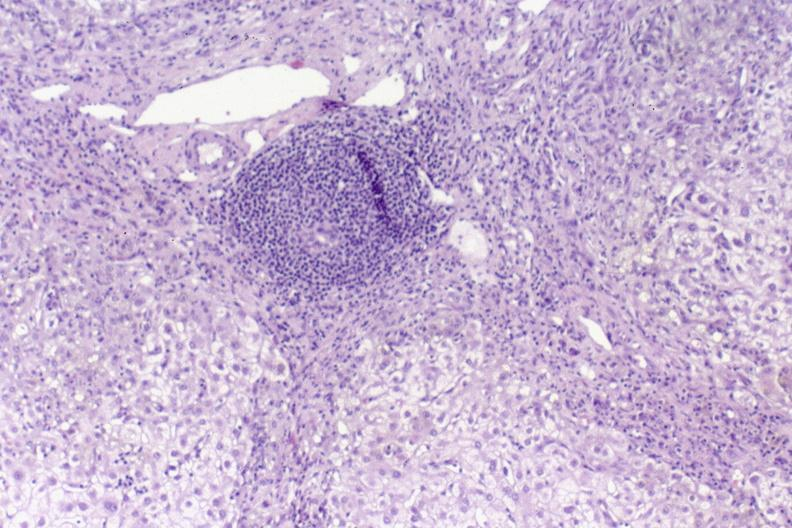what is present?
Answer the question using a single word or phrase. Liver 